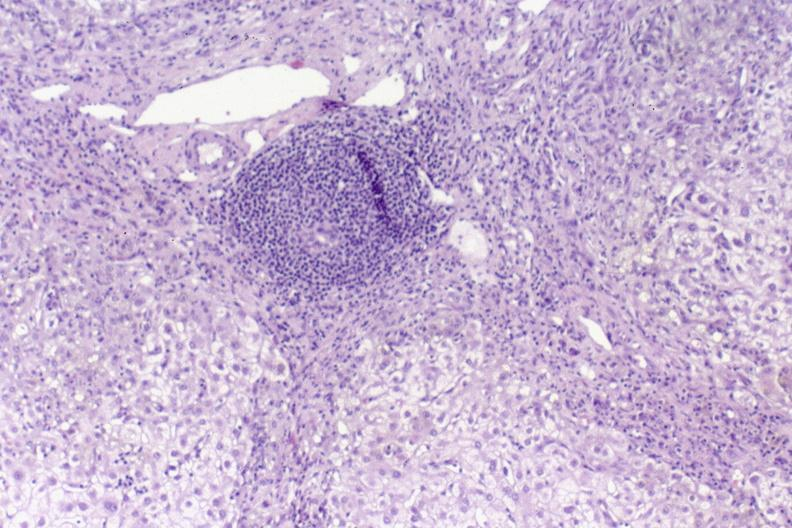what is present?
Answer the question using a single word or phrase. Liver 